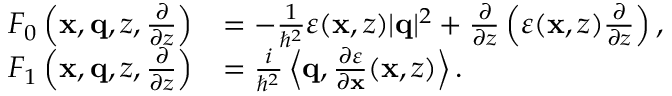<formula> <loc_0><loc_0><loc_500><loc_500>\begin{array} { r l } { F _ { 0 } \left ( x , q , z , \frac { \partial } { \partial z } \right ) } & { = - \frac { 1 } { \hbar { ^ } { 2 } } \varepsilon ( x , z ) | q | ^ { 2 } + \frac { \partial } { \partial z } \left ( \varepsilon ( x , z ) \frac { \partial } { \partial z } \right ) , } \\ { F _ { 1 } \left ( x , q , z , \frac { \partial } { \partial z } \right ) } & { = \frac { i } { \hbar { ^ } { 2 } } \left \langle q , \frac { \partial \varepsilon } { \partial x } ( x , z ) \right \rangle . } \end{array}</formula> 